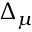Convert formula to latex. <formula><loc_0><loc_0><loc_500><loc_500>\Delta _ { \mu }</formula> 